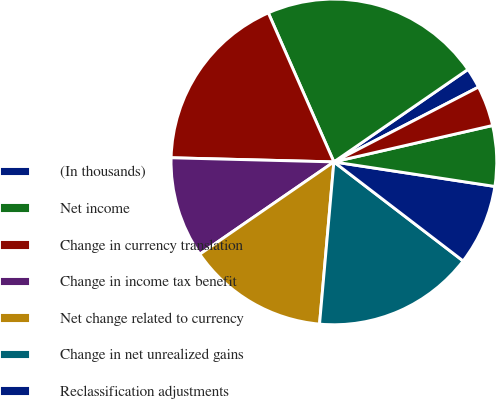<chart> <loc_0><loc_0><loc_500><loc_500><pie_chart><fcel>(In thousands)<fcel>Net income<fcel>Change in currency translation<fcel>Change in income tax benefit<fcel>Net change related to currency<fcel>Change in net unrealized gains<fcel>Reclassification adjustments<fcel>Net change related to cash<fcel>Net change related to<nl><fcel>2.01%<fcel>21.99%<fcel>18.0%<fcel>10.0%<fcel>14.0%<fcel>16.0%<fcel>8.0%<fcel>6.0%<fcel>4.01%<nl></chart> 